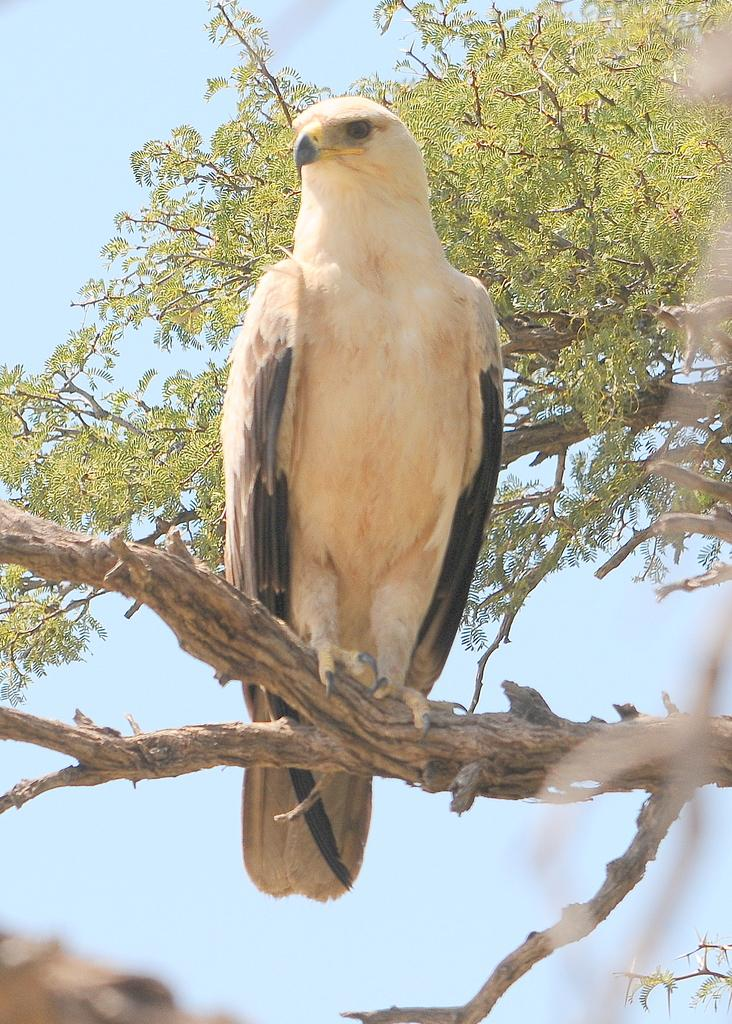What type of animal can be seen on the tree in the image? There is a bird visible on the trunk of a tree in the image. Can you describe the tree in the image? There is a tree in the image. What can be seen in the background of the image? The sky is visible in the image. What type of rhythm does the stove have in the image? There is no stove present in the image, so it is not possible to determine its rhythm. 